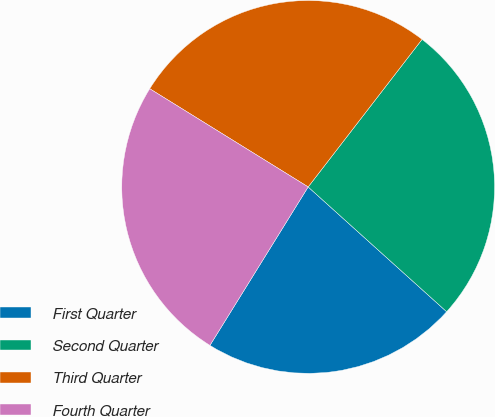Convert chart. <chart><loc_0><loc_0><loc_500><loc_500><pie_chart><fcel>First Quarter<fcel>Second Quarter<fcel>Third Quarter<fcel>Fourth Quarter<nl><fcel>22.16%<fcel>26.21%<fcel>26.63%<fcel>25.0%<nl></chart> 